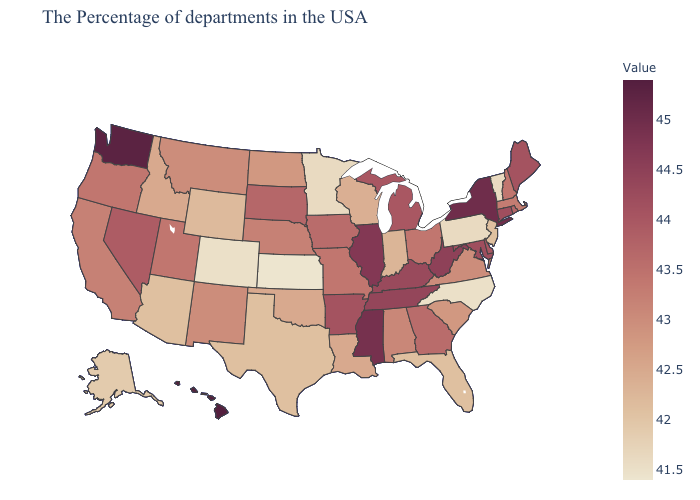Does Colorado have the lowest value in the West?
Answer briefly. Yes. Among the states that border Arkansas , does Texas have the lowest value?
Be succinct. Yes. Is the legend a continuous bar?
Concise answer only. Yes. Which states hav the highest value in the West?
Concise answer only. Hawaii. 